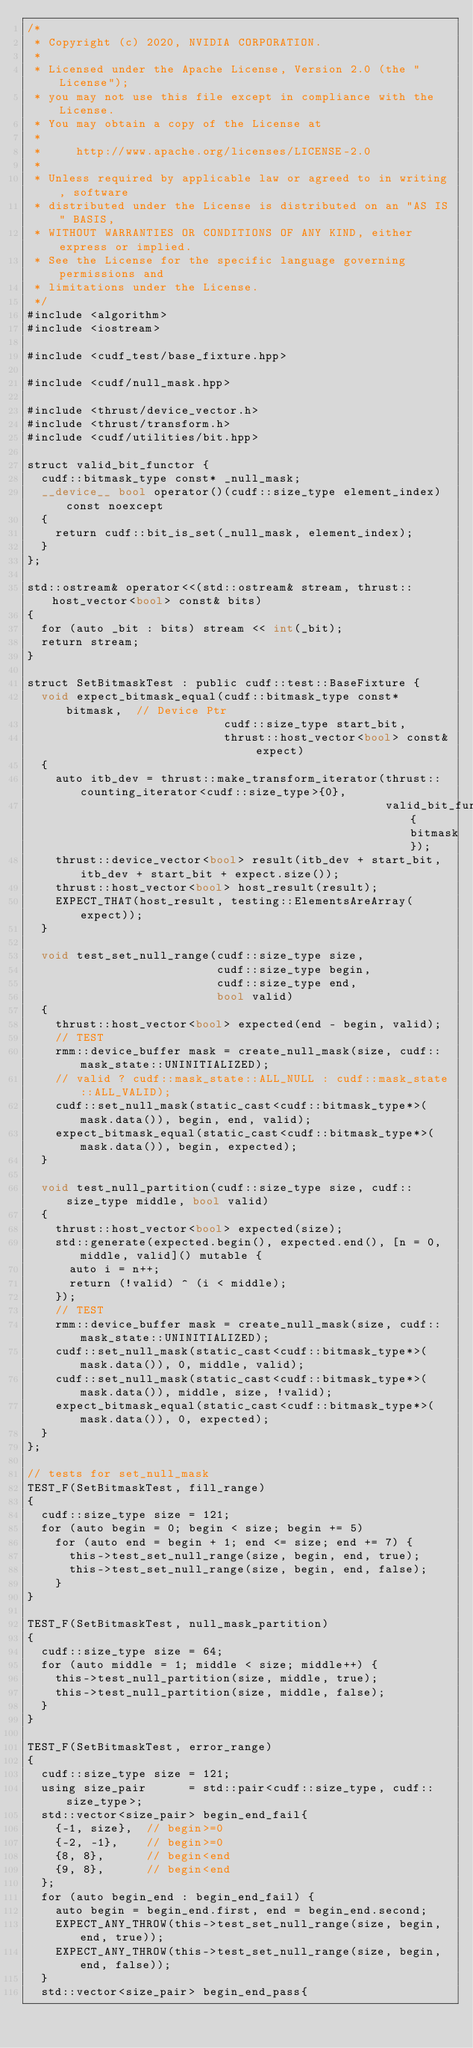<code> <loc_0><loc_0><loc_500><loc_500><_Cuda_>/*
 * Copyright (c) 2020, NVIDIA CORPORATION.
 *
 * Licensed under the Apache License, Version 2.0 (the "License");
 * you may not use this file except in compliance with the License.
 * You may obtain a copy of the License at
 *
 *     http://www.apache.org/licenses/LICENSE-2.0
 *
 * Unless required by applicable law or agreed to in writing, software
 * distributed under the License is distributed on an "AS IS" BASIS,
 * WITHOUT WARRANTIES OR CONDITIONS OF ANY KIND, either express or implied.
 * See the License for the specific language governing permissions and
 * limitations under the License.
 */
#include <algorithm>
#include <iostream>

#include <cudf_test/base_fixture.hpp>

#include <cudf/null_mask.hpp>

#include <thrust/device_vector.h>
#include <thrust/transform.h>
#include <cudf/utilities/bit.hpp>

struct valid_bit_functor {
  cudf::bitmask_type const* _null_mask;
  __device__ bool operator()(cudf::size_type element_index) const noexcept
  {
    return cudf::bit_is_set(_null_mask, element_index);
  }
};

std::ostream& operator<<(std::ostream& stream, thrust::host_vector<bool> const& bits)
{
  for (auto _bit : bits) stream << int(_bit);
  return stream;
}

struct SetBitmaskTest : public cudf::test::BaseFixture {
  void expect_bitmask_equal(cudf::bitmask_type const* bitmask,  // Device Ptr
                            cudf::size_type start_bit,
                            thrust::host_vector<bool> const& expect)
  {
    auto itb_dev = thrust::make_transform_iterator(thrust::counting_iterator<cudf::size_type>{0},
                                                   valid_bit_functor{bitmask});
    thrust::device_vector<bool> result(itb_dev + start_bit, itb_dev + start_bit + expect.size());
    thrust::host_vector<bool> host_result(result);
    EXPECT_THAT(host_result, testing::ElementsAreArray(expect));
  }

  void test_set_null_range(cudf::size_type size,
                           cudf::size_type begin,
                           cudf::size_type end,
                           bool valid)
  {
    thrust::host_vector<bool> expected(end - begin, valid);
    // TEST
    rmm::device_buffer mask = create_null_mask(size, cudf::mask_state::UNINITIALIZED);
    // valid ? cudf::mask_state::ALL_NULL : cudf::mask_state::ALL_VALID);
    cudf::set_null_mask(static_cast<cudf::bitmask_type*>(mask.data()), begin, end, valid);
    expect_bitmask_equal(static_cast<cudf::bitmask_type*>(mask.data()), begin, expected);
  }

  void test_null_partition(cudf::size_type size, cudf::size_type middle, bool valid)
  {
    thrust::host_vector<bool> expected(size);
    std::generate(expected.begin(), expected.end(), [n = 0, middle, valid]() mutable {
      auto i = n++;
      return (!valid) ^ (i < middle);
    });
    // TEST
    rmm::device_buffer mask = create_null_mask(size, cudf::mask_state::UNINITIALIZED);
    cudf::set_null_mask(static_cast<cudf::bitmask_type*>(mask.data()), 0, middle, valid);
    cudf::set_null_mask(static_cast<cudf::bitmask_type*>(mask.data()), middle, size, !valid);
    expect_bitmask_equal(static_cast<cudf::bitmask_type*>(mask.data()), 0, expected);
  }
};

// tests for set_null_mask
TEST_F(SetBitmaskTest, fill_range)
{
  cudf::size_type size = 121;
  for (auto begin = 0; begin < size; begin += 5)
    for (auto end = begin + 1; end <= size; end += 7) {
      this->test_set_null_range(size, begin, end, true);
      this->test_set_null_range(size, begin, end, false);
    }
}

TEST_F(SetBitmaskTest, null_mask_partition)
{
  cudf::size_type size = 64;
  for (auto middle = 1; middle < size; middle++) {
    this->test_null_partition(size, middle, true);
    this->test_null_partition(size, middle, false);
  }
}

TEST_F(SetBitmaskTest, error_range)
{
  cudf::size_type size = 121;
  using size_pair      = std::pair<cudf::size_type, cudf::size_type>;
  std::vector<size_pair> begin_end_fail{
    {-1, size},  // begin>=0
    {-2, -1},    // begin>=0
    {8, 8},      // begin<end
    {9, 8},      // begin<end
  };
  for (auto begin_end : begin_end_fail) {
    auto begin = begin_end.first, end = begin_end.second;
    EXPECT_ANY_THROW(this->test_set_null_range(size, begin, end, true));
    EXPECT_ANY_THROW(this->test_set_null_range(size, begin, end, false));
  }
  std::vector<size_pair> begin_end_pass{</code> 